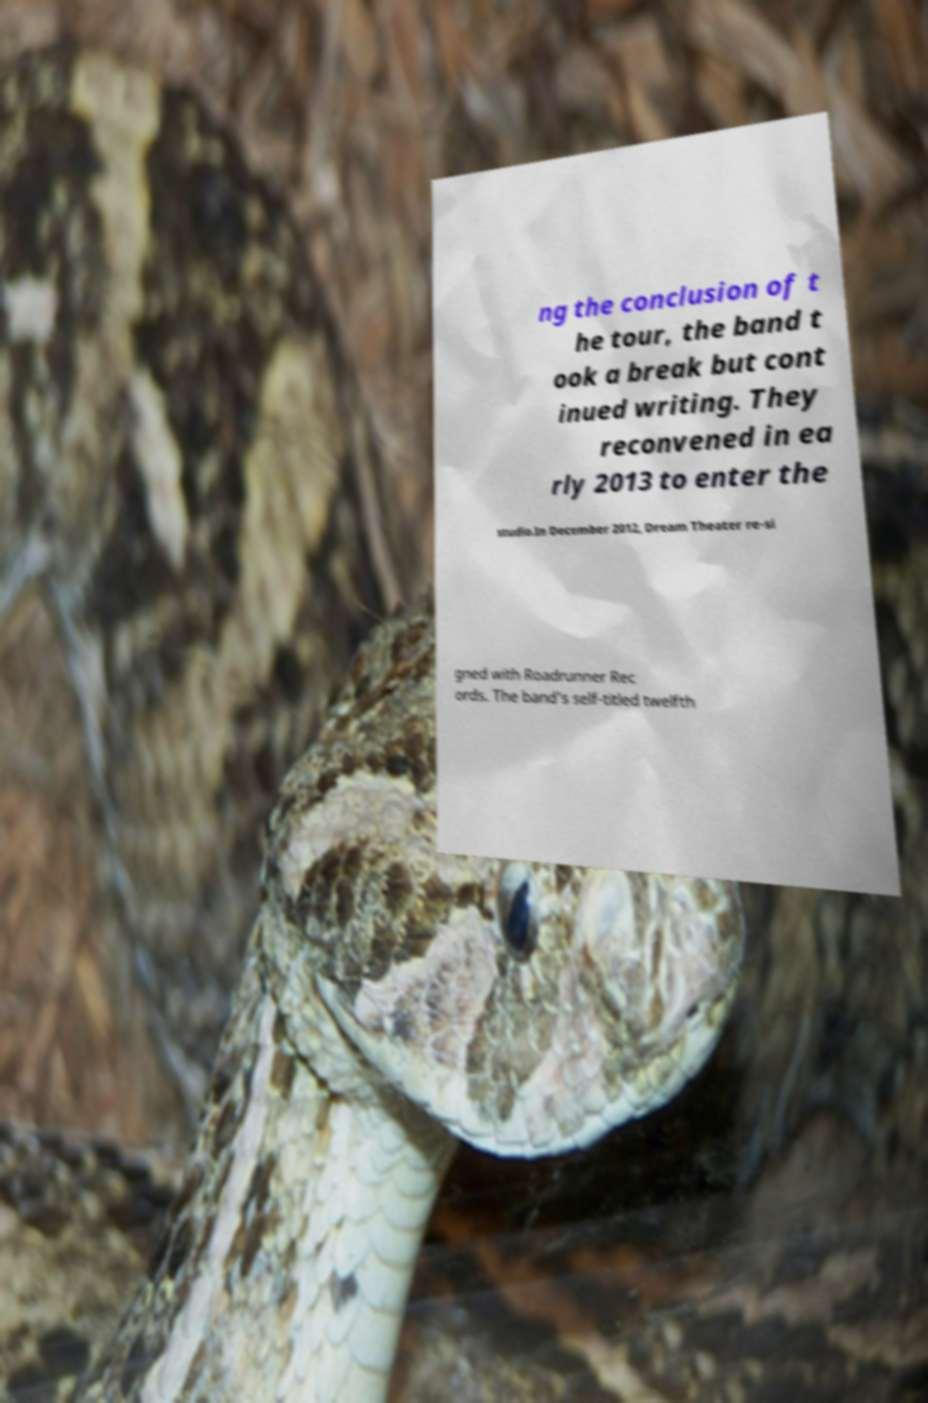Please identify and transcribe the text found in this image. ng the conclusion of t he tour, the band t ook a break but cont inued writing. They reconvened in ea rly 2013 to enter the studio.In December 2012, Dream Theater re-si gned with Roadrunner Rec ords. The band's self-titled twelfth 